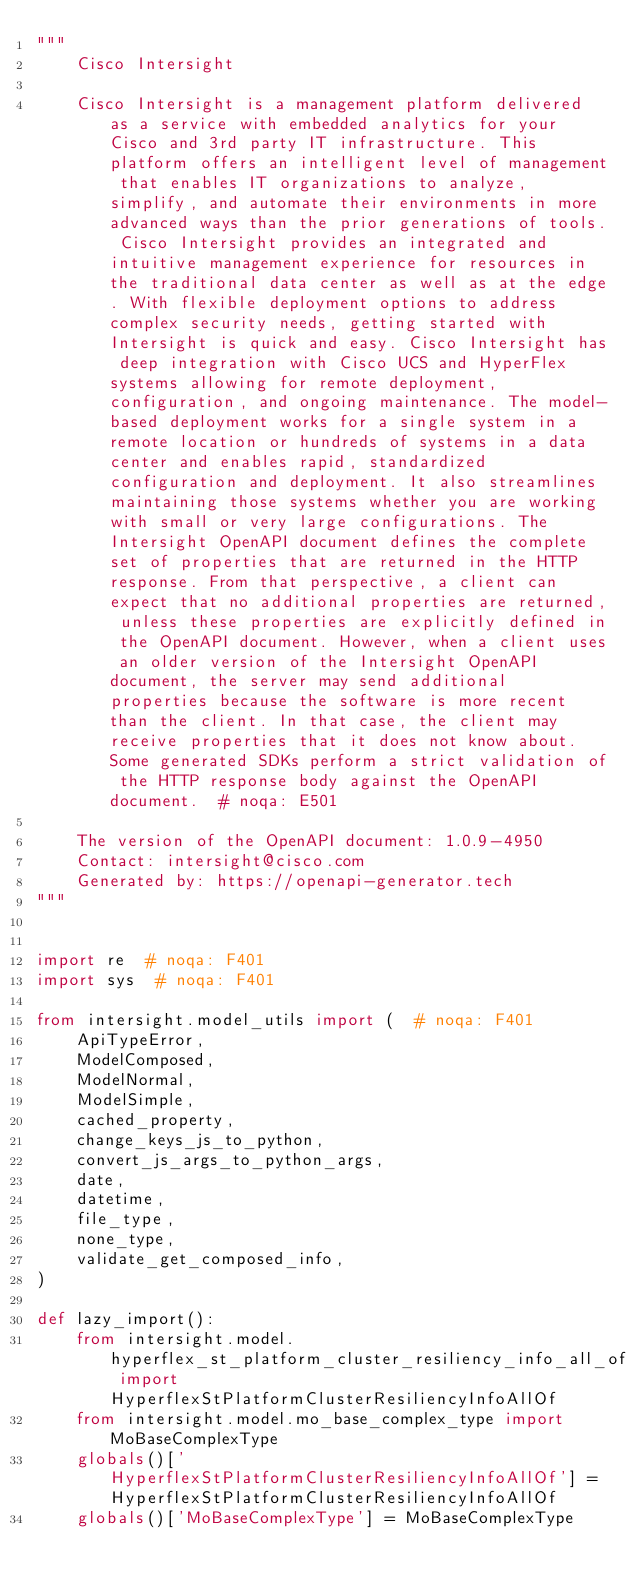<code> <loc_0><loc_0><loc_500><loc_500><_Python_>"""
    Cisco Intersight

    Cisco Intersight is a management platform delivered as a service with embedded analytics for your Cisco and 3rd party IT infrastructure. This platform offers an intelligent level of management that enables IT organizations to analyze, simplify, and automate their environments in more advanced ways than the prior generations of tools. Cisco Intersight provides an integrated and intuitive management experience for resources in the traditional data center as well as at the edge. With flexible deployment options to address complex security needs, getting started with Intersight is quick and easy. Cisco Intersight has deep integration with Cisco UCS and HyperFlex systems allowing for remote deployment, configuration, and ongoing maintenance. The model-based deployment works for a single system in a remote location or hundreds of systems in a data center and enables rapid, standardized configuration and deployment. It also streamlines maintaining those systems whether you are working with small or very large configurations. The Intersight OpenAPI document defines the complete set of properties that are returned in the HTTP response. From that perspective, a client can expect that no additional properties are returned, unless these properties are explicitly defined in the OpenAPI document. However, when a client uses an older version of the Intersight OpenAPI document, the server may send additional properties because the software is more recent than the client. In that case, the client may receive properties that it does not know about. Some generated SDKs perform a strict validation of the HTTP response body against the OpenAPI document.  # noqa: E501

    The version of the OpenAPI document: 1.0.9-4950
    Contact: intersight@cisco.com
    Generated by: https://openapi-generator.tech
"""


import re  # noqa: F401
import sys  # noqa: F401

from intersight.model_utils import (  # noqa: F401
    ApiTypeError,
    ModelComposed,
    ModelNormal,
    ModelSimple,
    cached_property,
    change_keys_js_to_python,
    convert_js_args_to_python_args,
    date,
    datetime,
    file_type,
    none_type,
    validate_get_composed_info,
)

def lazy_import():
    from intersight.model.hyperflex_st_platform_cluster_resiliency_info_all_of import HyperflexStPlatformClusterResiliencyInfoAllOf
    from intersight.model.mo_base_complex_type import MoBaseComplexType
    globals()['HyperflexStPlatformClusterResiliencyInfoAllOf'] = HyperflexStPlatformClusterResiliencyInfoAllOf
    globals()['MoBaseComplexType'] = MoBaseComplexType

</code> 